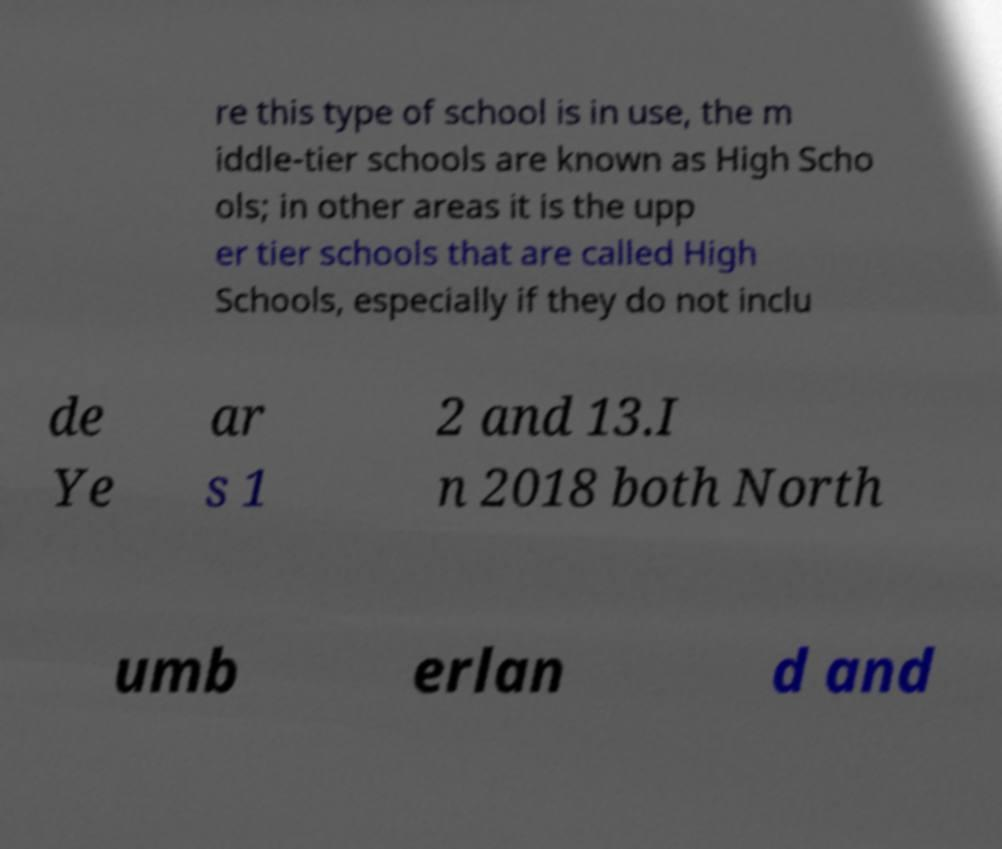What messages or text are displayed in this image? I need them in a readable, typed format. re this type of school is in use, the m iddle-tier schools are known as High Scho ols; in other areas it is the upp er tier schools that are called High Schools, especially if they do not inclu de Ye ar s 1 2 and 13.I n 2018 both North umb erlan d and 